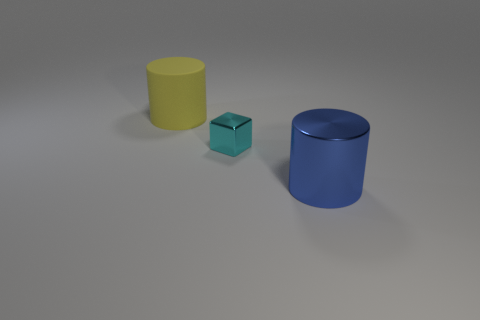What number of big objects are gray rubber cubes or cylinders?
Your answer should be very brief. 2. What material is the other big object that is the same shape as the big matte object?
Offer a very short reply. Metal. Are there any other things that have the same material as the tiny thing?
Provide a short and direct response. Yes. The rubber object is what color?
Provide a short and direct response. Yellow. Is the big matte object the same color as the big metal cylinder?
Offer a terse response. No. There is a large cylinder that is on the right side of the yellow rubber thing; what number of small cyan things are to the right of it?
Your answer should be very brief. 0. What size is the thing that is in front of the yellow thing and behind the metallic cylinder?
Make the answer very short. Small. There is a large object that is left of the cyan metal object; what is it made of?
Make the answer very short. Rubber. Is there another object that has the same shape as the yellow thing?
Offer a very short reply. Yes. How many other big things have the same shape as the big blue thing?
Offer a terse response. 1. 